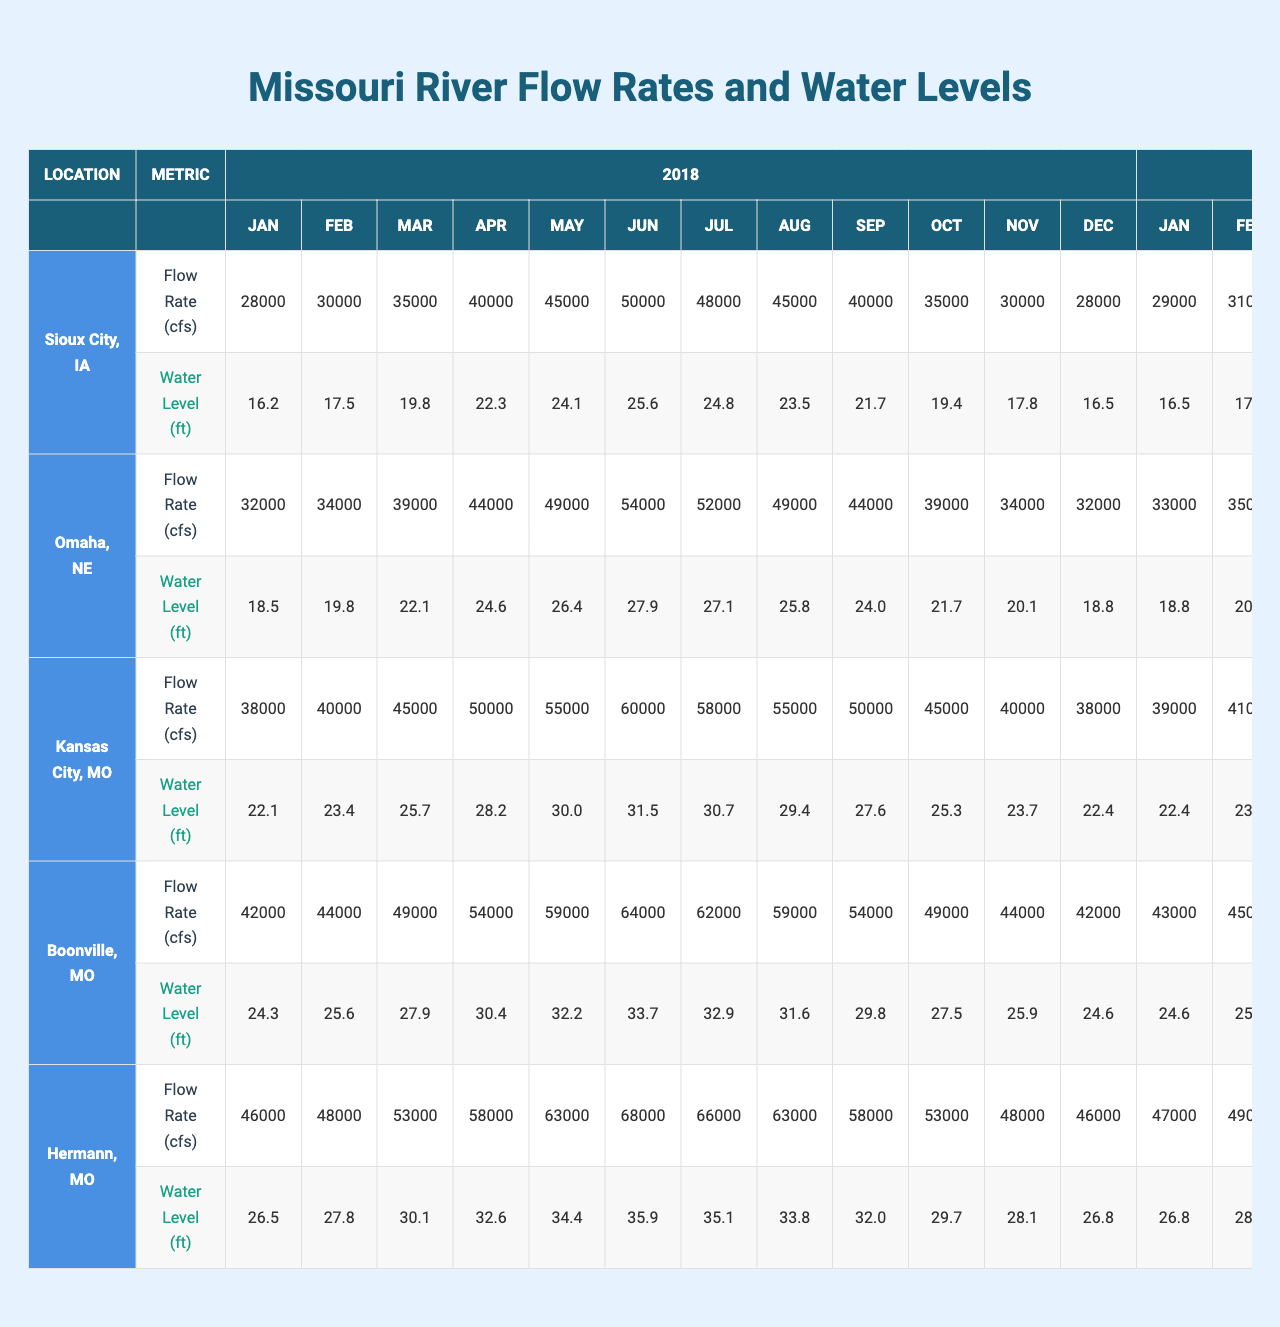What was the flow rate in Kansas City, MO in June 2021? Referring to the table, look under Kansas City, MO in the row corresponding to June 2021. The flow rate for that month is listed as 52000 cfs.
Answer: 52000 cfs What was the highest water level recorded in Hermann, MO during 2022? In the Hermann, MO section for 2022, check the water level values for each month. The highest water level appears in June at 35.0 feet.
Answer: 35.0 feet What is the average flow rate for Sioux City, IA across all months in 2019? To find the average flow rate in Sioux City, IA for 2019, sum the flow rates from each month: (29000 + 31000 + 36000 + 41000 + 46000 + 51000 + 49000 + 46000 + 41000 + 36000 + 31000 + 29000) = 547000. Divide this sum by 12 (number of months) gives an average of 45616.67, rounded to 45617.
Answer: 45617 cfs Was the water level in Omaha, NE higher in July 2020 than in July 2021? Look at the table for Omaha, NE July data: the water level in July 2020 is 27.6 feet, while in July 2021 it is 27.3 feet. Since 27.6 feet > 27.3 feet, the statement is true.
Answer: Yes In which month did Boonville, MO have the lowest flow rate in 2022? In the Boonville, MO section for 2022, review the flow rate values. The lowest flow rate appears in December with 39000 cfs.
Answer: December How much did the average water level in Kansas City, MO increase from 2020 to 2021? First, find the average water level for Kansas City, MO in 2020: (21.8 + 23.1 + 25.4 + 27.9 + 29.7 + 31.2 + 30.4 + 29.1 + 27.3 + 25.0 + 23.4 + 22.1) =  25.3. Next, find the average for 2021: (21.5 + 22.8 + 25.1 + 27.6 + 29.4 + 30.9 + 30.1 + 28.8 + 27.0 + 24.7 + 23.1 + 21.8) = 25.4. Finally, calculate the difference: 25.4 - 25.3 = 0.1.
Answer: 0.1 feet Did water levels in Hermann, MO reach below 26 feet at any point during 2022? In the Hermann, MO 2022 data, the lowest water level recorded is 25.6 feet in January, which is below 26 feet. Therefore, the statement is true.
Answer: Yes Which location had the highest average flow rate across all months in 2021? Calculate the monthly average flow rates for each location in 2021. After checking flow rates, Kansas City has the highest average at 48400 cfs.
Answer: Kansas City, MO What was the trend in flow rates for Sioux City, IA from 2018 to 2022? Review the yearly flow rates for Sioux City, IA. The numbers show a decline from 2018 to 2022 (28000, 29000, 27000, 26000, 25000). Therefore, the trend is a decrease.
Answer: Decrease What is the average water level for Omaha, NE in 2019? To find the average, calculate the sum of all monthly water levels in 2019: (18.8 + 20.1 + 22.4 + 24.9 + 26.7 + 28.2 + 27.4 + 26.1 + 24.3 + 22.0 + 20.4 + 19.1) = 25.2, then divide by 12 for an average of 21.09, rounded gives 21.1.
Answer: 21.1 feet 